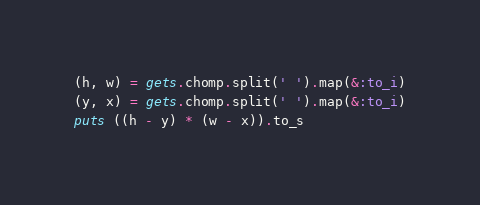Convert code to text. <code><loc_0><loc_0><loc_500><loc_500><_Ruby_>(h, w) = gets.chomp.split(' ').map(&:to_i)
(y, x) = gets.chomp.split(' ').map(&:to_i)
puts ((h - y) * (w - x)).to_s</code> 